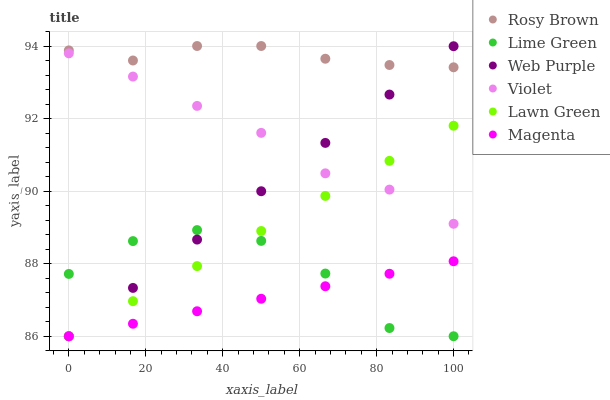Does Magenta have the minimum area under the curve?
Answer yes or no. Yes. Does Rosy Brown have the maximum area under the curve?
Answer yes or no. Yes. Does Web Purple have the minimum area under the curve?
Answer yes or no. No. Does Web Purple have the maximum area under the curve?
Answer yes or no. No. Is Lawn Green the smoothest?
Answer yes or no. Yes. Is Lime Green the roughest?
Answer yes or no. Yes. Is Rosy Brown the smoothest?
Answer yes or no. No. Is Rosy Brown the roughest?
Answer yes or no. No. Does Lawn Green have the lowest value?
Answer yes or no. Yes. Does Rosy Brown have the lowest value?
Answer yes or no. No. Does Rosy Brown have the highest value?
Answer yes or no. Yes. Does Web Purple have the highest value?
Answer yes or no. No. Is Violet less than Rosy Brown?
Answer yes or no. Yes. Is Violet greater than Magenta?
Answer yes or no. Yes. Does Rosy Brown intersect Web Purple?
Answer yes or no. Yes. Is Rosy Brown less than Web Purple?
Answer yes or no. No. Is Rosy Brown greater than Web Purple?
Answer yes or no. No. Does Violet intersect Rosy Brown?
Answer yes or no. No. 